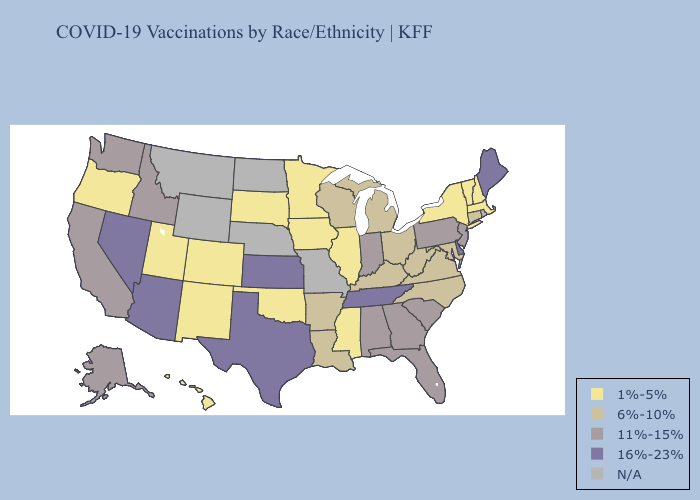What is the value of Kansas?
Be succinct. 16%-23%. Does Louisiana have the lowest value in the USA?
Answer briefly. No. Name the states that have a value in the range 11%-15%?
Short answer required. Alabama, Alaska, California, Florida, Georgia, Idaho, Indiana, New Jersey, Pennsylvania, South Carolina, Washington. Name the states that have a value in the range 6%-10%?
Answer briefly. Arkansas, Connecticut, Kentucky, Louisiana, Maryland, Michigan, North Carolina, Ohio, Virginia, West Virginia, Wisconsin. Which states have the lowest value in the MidWest?
Answer briefly. Illinois, Iowa, Minnesota, South Dakota. Which states hav the highest value in the MidWest?
Be succinct. Kansas. Among the states that border Texas , which have the lowest value?
Short answer required. New Mexico, Oklahoma. Among the states that border New Jersey , does New York have the highest value?
Short answer required. No. What is the lowest value in states that border North Carolina?
Concise answer only. 6%-10%. Among the states that border Louisiana , which have the lowest value?
Answer briefly. Mississippi. What is the highest value in the South ?
Short answer required. 16%-23%. What is the value of New York?
Short answer required. 1%-5%. Name the states that have a value in the range N/A?
Concise answer only. Missouri, Montana, Nebraska, North Dakota, Rhode Island, Wyoming. How many symbols are there in the legend?
Be succinct. 5. Does Tennessee have the highest value in the South?
Concise answer only. Yes. 